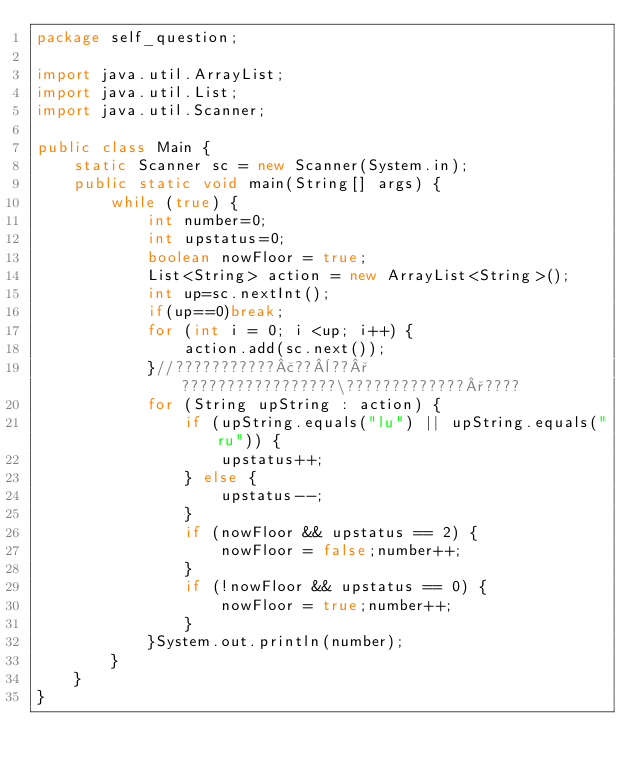<code> <loc_0><loc_0><loc_500><loc_500><_Java_>package self_question;

import java.util.ArrayList;
import java.util.List;
import java.util.Scanner;

public class Main {
    static Scanner sc = new Scanner(System.in);
    public static void main(String[] args) {
        while (true) {
            int number=0;
            int upstatus=0;
            boolean nowFloor = true;
            List<String> action = new ArrayList<String>();
            int up=sc.nextInt();
            if(up==0)break;
            for (int i = 0; i <up; i++) {
                action.add(sc.next());
            }//???????????£??¨??°?????????????????\?????????????°????
            for (String upString : action) {
                if (upString.equals("lu") || upString.equals("ru")) {
                    upstatus++;
                } else {
                    upstatus--;
                }
                if (nowFloor && upstatus == 2) {
                    nowFloor = false;number++;
                }
                if (!nowFloor && upstatus == 0) {
                    nowFloor = true;number++;
                }
            }System.out.println(number);
        }
    }
}</code> 